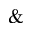<formula> <loc_0><loc_0><loc_500><loc_500>\&</formula> 